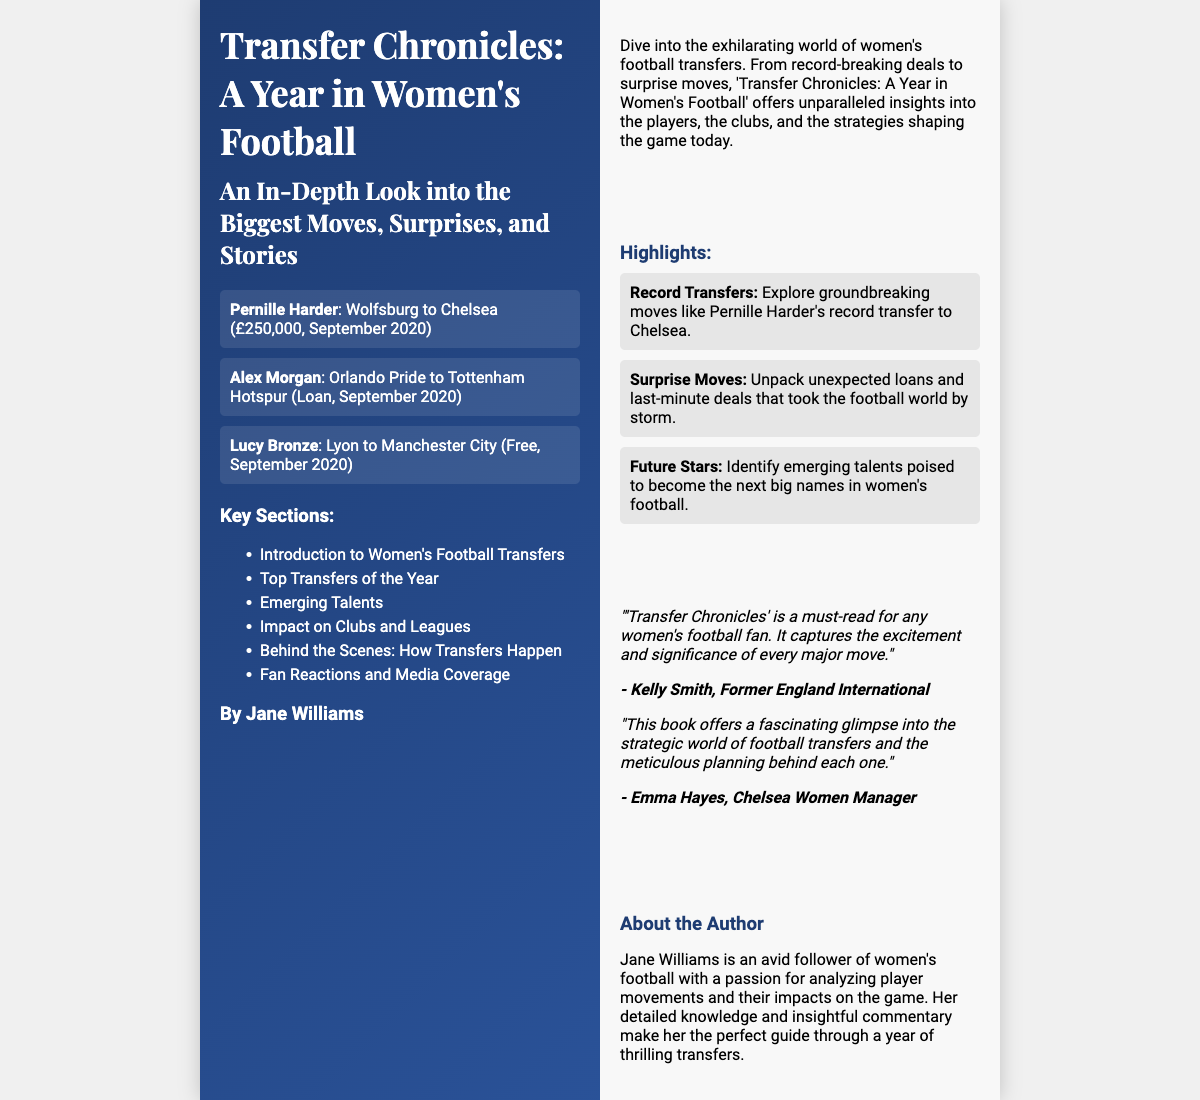What is the title of the book? The title is prominently displayed on the front cover of the document.
Answer: Transfer Chronicles: A Year in Women's Football Who is the author of the book? The author name is provided in the author section on the front cover.
Answer: Jane Williams What significant transfer involved Pernille Harder? The information about transfer deals is listed on the front cover, specifying details about notable transfers.
Answer: Wolfsburg to Chelsea (£250,000) What club did Alex Morgan move to? This is mentioned in the transfer list on the front cover, detailing her transfer.
Answer: Tottenham Hotspur How many key sections are mentioned? The number of sections is found in the list of key sections on the front cover.
Answer: 6 What type of endorsements does the book receive? Endorsements by notable individuals are included on the back cover, highlighting the book's reception.
Answer: Positive What is one highlight discussed in the book? Highlights are specifically outlined on the back cover, detailing interesting aspects of the content.
Answer: Record Transfers Which player’s transfer is noted as surprising? The highlights section describes various aspects of transfers, including surprising moves.
Answer: None specified (general concept) What role does Jane Williams have in women's football? The author bio provides insights into her relationship with the sport.
Answer: Analyst 